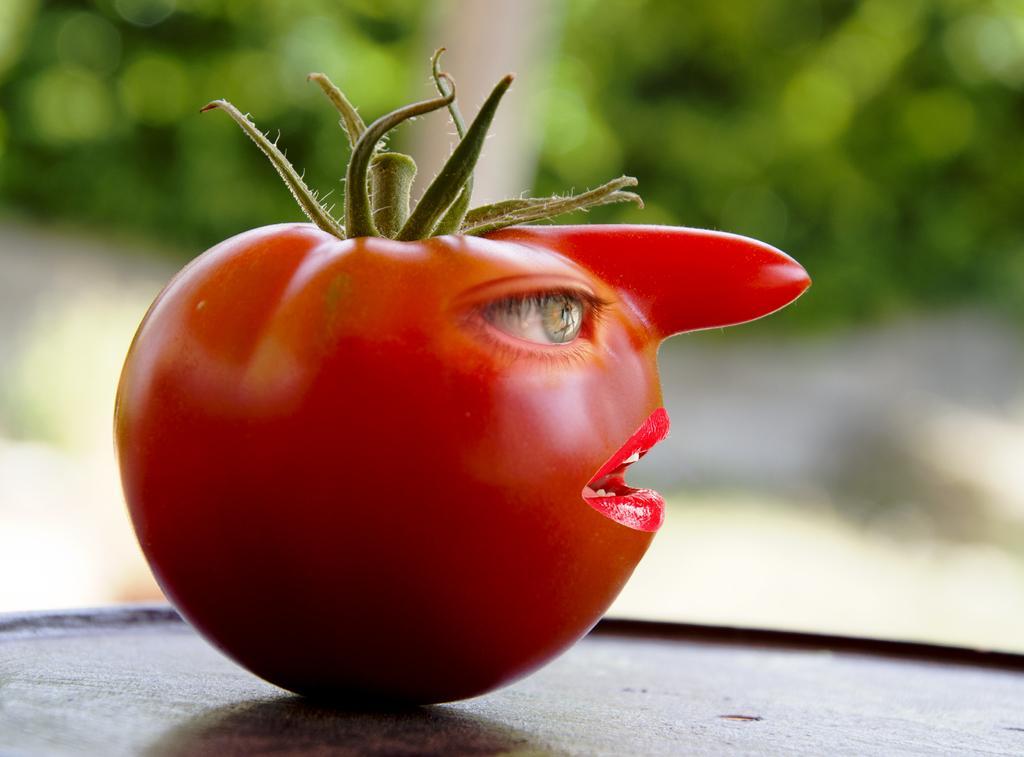Could you give a brief overview of what you see in this image? In this picture there is a tomato in the image, on which there is an eye, nose, and lips. 